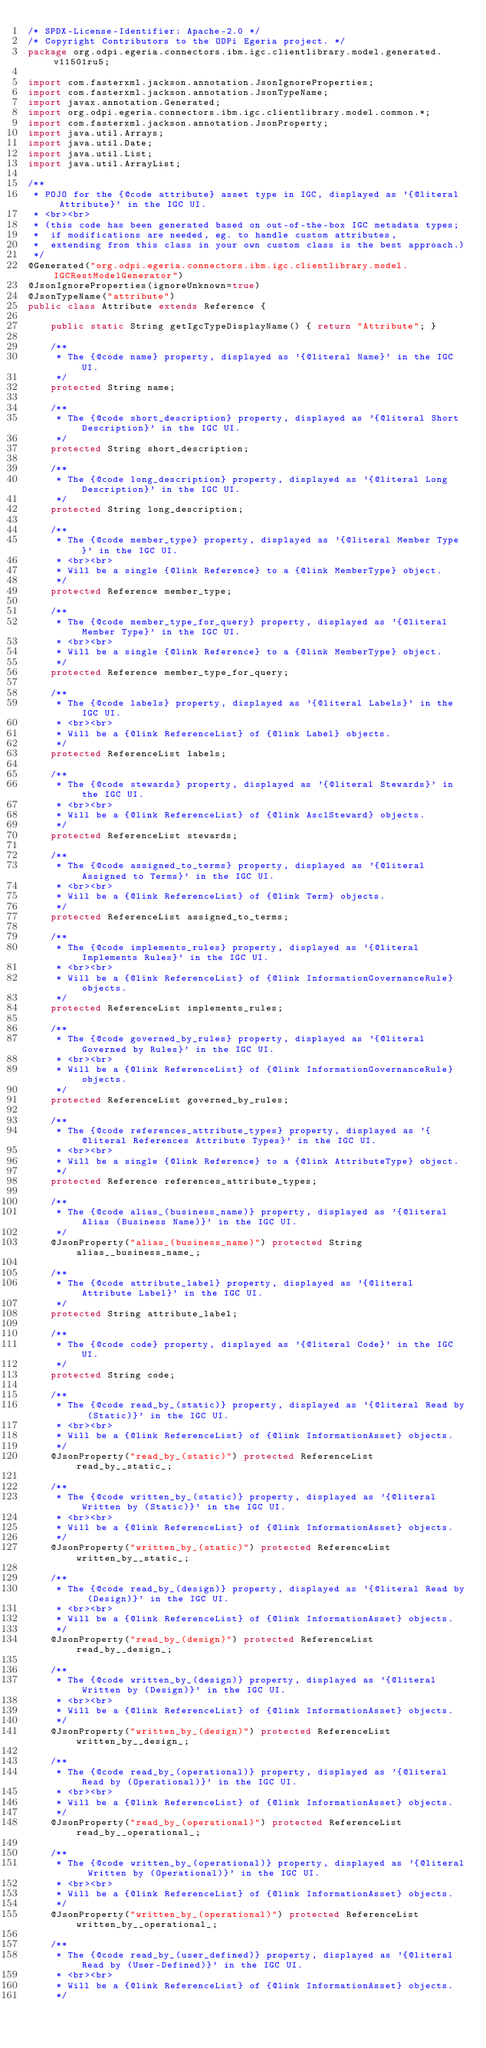<code> <loc_0><loc_0><loc_500><loc_500><_Java_>/* SPDX-License-Identifier: Apache-2.0 */
/* Copyright Contributors to the ODPi Egeria project. */
package org.odpi.egeria.connectors.ibm.igc.clientlibrary.model.generated.v11501ru5;

import com.fasterxml.jackson.annotation.JsonIgnoreProperties;
import com.fasterxml.jackson.annotation.JsonTypeName;
import javax.annotation.Generated;
import org.odpi.egeria.connectors.ibm.igc.clientlibrary.model.common.*;
import com.fasterxml.jackson.annotation.JsonProperty;
import java.util.Arrays;
import java.util.Date;
import java.util.List;
import java.util.ArrayList;

/**
 * POJO for the {@code attribute} asset type in IGC, displayed as '{@literal Attribute}' in the IGC UI.
 * <br><br>
 * (this code has been generated based on out-of-the-box IGC metadata types;
 *  if modifications are needed, eg. to handle custom attributes,
 *  extending from this class in your own custom class is the best approach.)
 */
@Generated("org.odpi.egeria.connectors.ibm.igc.clientlibrary.model.IGCRestModelGenerator")
@JsonIgnoreProperties(ignoreUnknown=true)
@JsonTypeName("attribute")
public class Attribute extends Reference {

    public static String getIgcTypeDisplayName() { return "Attribute"; }

    /**
     * The {@code name} property, displayed as '{@literal Name}' in the IGC UI.
     */
    protected String name;

    /**
     * The {@code short_description} property, displayed as '{@literal Short Description}' in the IGC UI.
     */
    protected String short_description;

    /**
     * The {@code long_description} property, displayed as '{@literal Long Description}' in the IGC UI.
     */
    protected String long_description;

    /**
     * The {@code member_type} property, displayed as '{@literal Member Type}' in the IGC UI.
     * <br><br>
     * Will be a single {@link Reference} to a {@link MemberType} object.
     */
    protected Reference member_type;

    /**
     * The {@code member_type_for_query} property, displayed as '{@literal Member Type}' in the IGC UI.
     * <br><br>
     * Will be a single {@link Reference} to a {@link MemberType} object.
     */
    protected Reference member_type_for_query;

    /**
     * The {@code labels} property, displayed as '{@literal Labels}' in the IGC UI.
     * <br><br>
     * Will be a {@link ReferenceList} of {@link Label} objects.
     */
    protected ReferenceList labels;

    /**
     * The {@code stewards} property, displayed as '{@literal Stewards}' in the IGC UI.
     * <br><br>
     * Will be a {@link ReferenceList} of {@link AsclSteward} objects.
     */
    protected ReferenceList stewards;

    /**
     * The {@code assigned_to_terms} property, displayed as '{@literal Assigned to Terms}' in the IGC UI.
     * <br><br>
     * Will be a {@link ReferenceList} of {@link Term} objects.
     */
    protected ReferenceList assigned_to_terms;

    /**
     * The {@code implements_rules} property, displayed as '{@literal Implements Rules}' in the IGC UI.
     * <br><br>
     * Will be a {@link ReferenceList} of {@link InformationGovernanceRule} objects.
     */
    protected ReferenceList implements_rules;

    /**
     * The {@code governed_by_rules} property, displayed as '{@literal Governed by Rules}' in the IGC UI.
     * <br><br>
     * Will be a {@link ReferenceList} of {@link InformationGovernanceRule} objects.
     */
    protected ReferenceList governed_by_rules;

    /**
     * The {@code references_attribute_types} property, displayed as '{@literal References Attribute Types}' in the IGC UI.
     * <br><br>
     * Will be a single {@link Reference} to a {@link AttributeType} object.
     */
    protected Reference references_attribute_types;

    /**
     * The {@code alias_(business_name)} property, displayed as '{@literal Alias (Business Name)}' in the IGC UI.
     */
    @JsonProperty("alias_(business_name)") protected String alias__business_name_;

    /**
     * The {@code attribute_label} property, displayed as '{@literal Attribute Label}' in the IGC UI.
     */
    protected String attribute_label;

    /**
     * The {@code code} property, displayed as '{@literal Code}' in the IGC UI.
     */
    protected String code;

    /**
     * The {@code read_by_(static)} property, displayed as '{@literal Read by (Static)}' in the IGC UI.
     * <br><br>
     * Will be a {@link ReferenceList} of {@link InformationAsset} objects.
     */
    @JsonProperty("read_by_(static)") protected ReferenceList read_by__static_;

    /**
     * The {@code written_by_(static)} property, displayed as '{@literal Written by (Static)}' in the IGC UI.
     * <br><br>
     * Will be a {@link ReferenceList} of {@link InformationAsset} objects.
     */
    @JsonProperty("written_by_(static)") protected ReferenceList written_by__static_;

    /**
     * The {@code read_by_(design)} property, displayed as '{@literal Read by (Design)}' in the IGC UI.
     * <br><br>
     * Will be a {@link ReferenceList} of {@link InformationAsset} objects.
     */
    @JsonProperty("read_by_(design)") protected ReferenceList read_by__design_;

    /**
     * The {@code written_by_(design)} property, displayed as '{@literal Written by (Design)}' in the IGC UI.
     * <br><br>
     * Will be a {@link ReferenceList} of {@link InformationAsset} objects.
     */
    @JsonProperty("written_by_(design)") protected ReferenceList written_by__design_;

    /**
     * The {@code read_by_(operational)} property, displayed as '{@literal Read by (Operational)}' in the IGC UI.
     * <br><br>
     * Will be a {@link ReferenceList} of {@link InformationAsset} objects.
     */
    @JsonProperty("read_by_(operational)") protected ReferenceList read_by__operational_;

    /**
     * The {@code written_by_(operational)} property, displayed as '{@literal Written by (Operational)}' in the IGC UI.
     * <br><br>
     * Will be a {@link ReferenceList} of {@link InformationAsset} objects.
     */
    @JsonProperty("written_by_(operational)") protected ReferenceList written_by__operational_;

    /**
     * The {@code read_by_(user_defined)} property, displayed as '{@literal Read by (User-Defined)}' in the IGC UI.
     * <br><br>
     * Will be a {@link ReferenceList} of {@link InformationAsset} objects.
     */</code> 